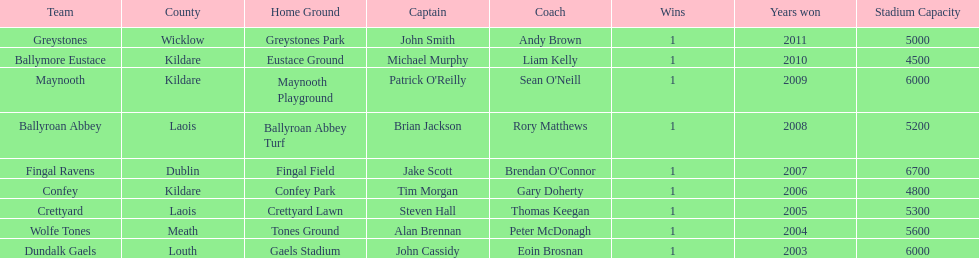What is the last team on the chart Dundalk Gaels. 